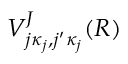<formula> <loc_0><loc_0><loc_500><loc_500>V _ { j \kappa _ { j } , j ^ { \prime } \kappa _ { j } } ^ { J } ( R )</formula> 